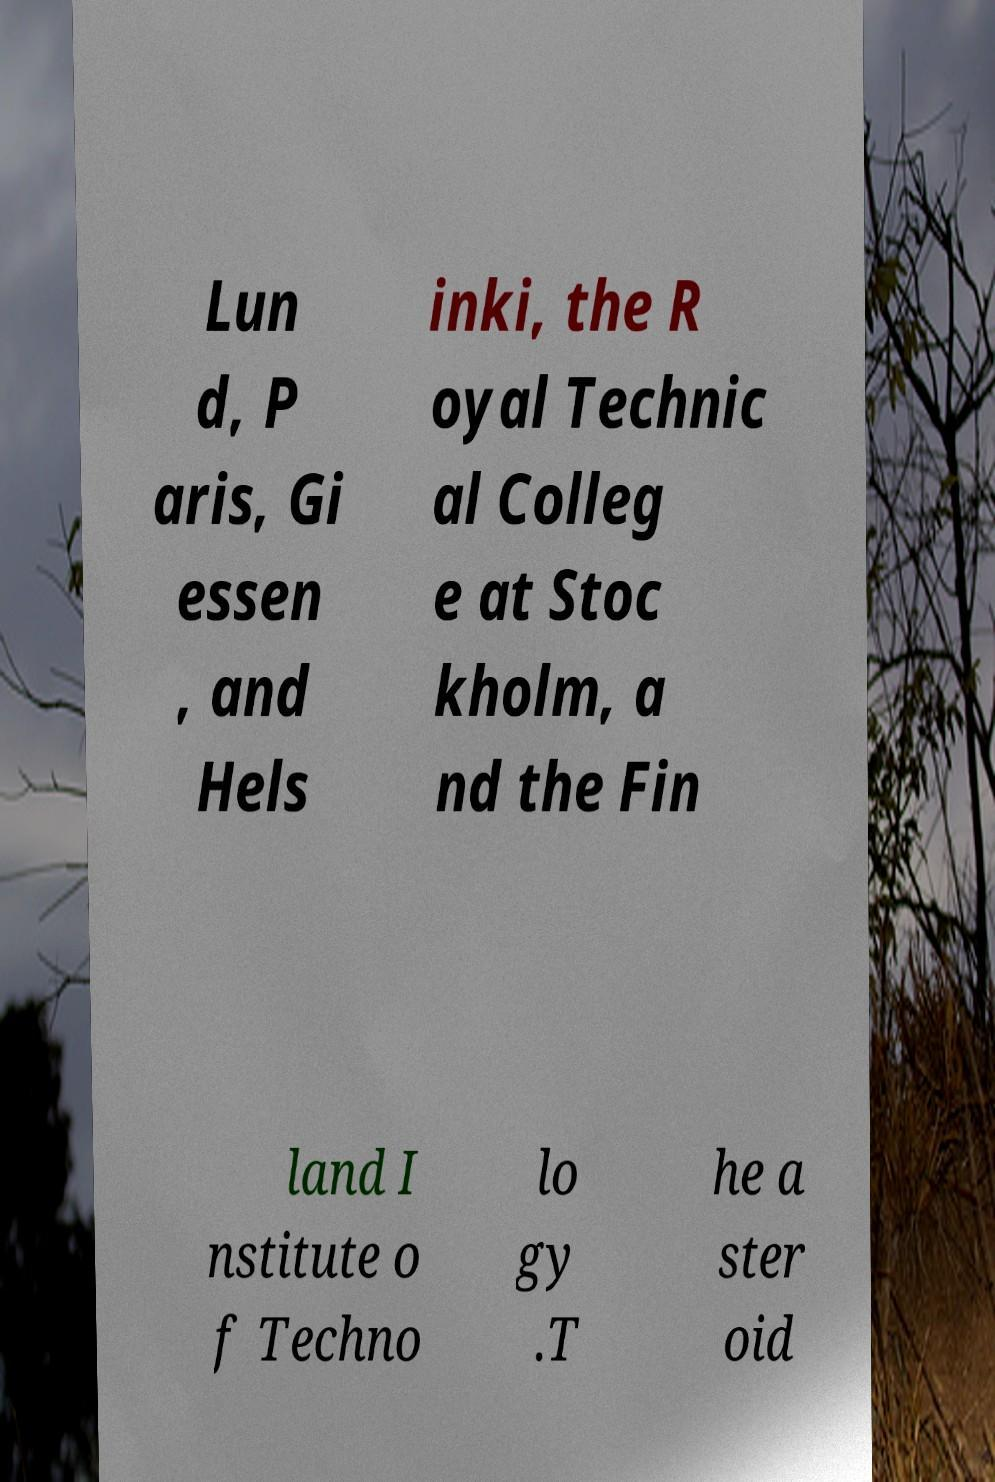Can you read and provide the text displayed in the image?This photo seems to have some interesting text. Can you extract and type it out for me? Lun d, P aris, Gi essen , and Hels inki, the R oyal Technic al Colleg e at Stoc kholm, a nd the Fin land I nstitute o f Techno lo gy .T he a ster oid 